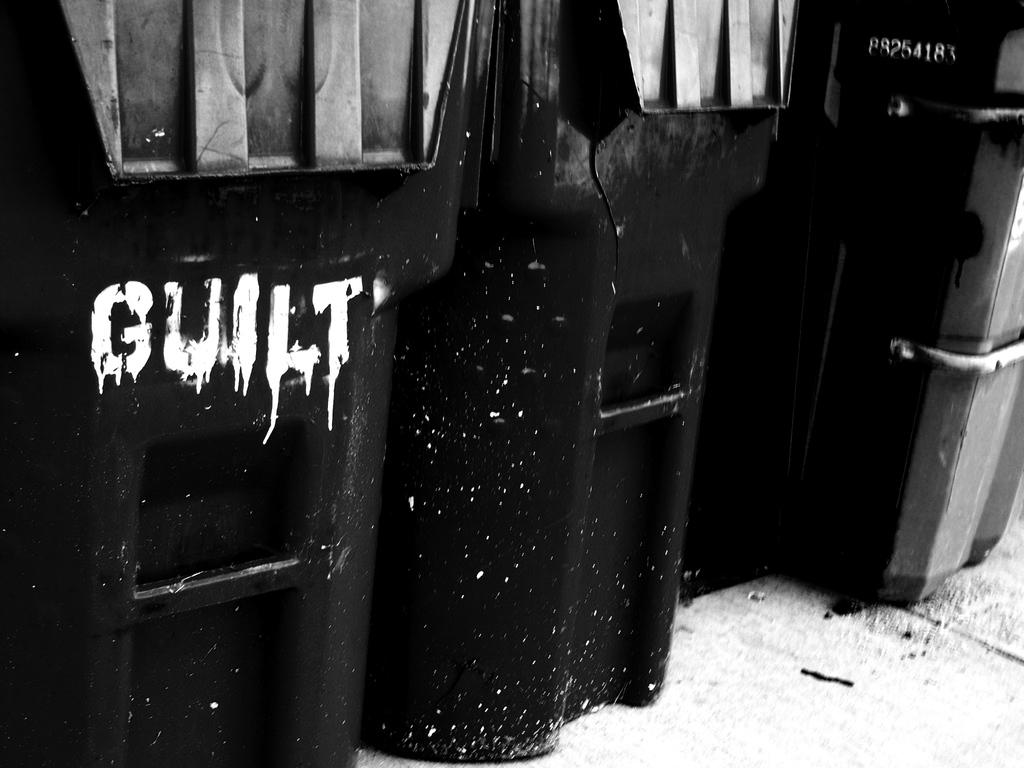What objects are present in the image? There are multiple bins in the image. How are the bins arranged? The bins are arranged in a row. Is there any text or labeling on any of the bins? Yes, the word "GUILT" is written on one of the bins. What type of error can be seen on the dock in the image? There is no dock or error present in the image; it only features multiple bins arranged in a row with the word "GUILT" written on one of them. 